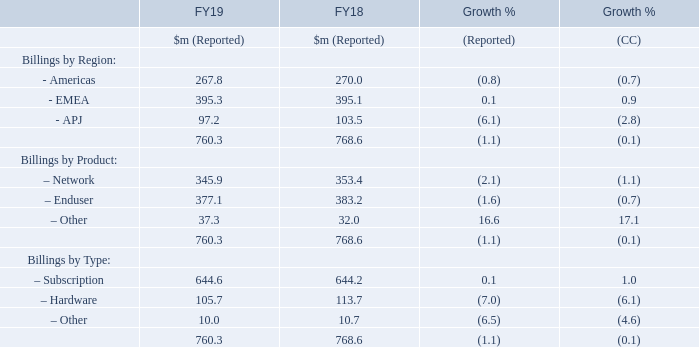Billings
Group reported billings decreased by $8.3 million or 1.1 per cent to $760.3 million in the year-ended 31 March 2019. This represented a 0.1 per cent decrease on a constant currency (“CC”) basis.
Billings by region
Americas Billings attributable to the Americas decreased by $2.2 million to $267.8 million in the period, representing a 0.8 per cent reduction on a reported basis and 0.7 per cent on a constant currency basis; this decrease largely driven by a decline in Enduser products due to the stronger performance in the prior-year compare as a consequence of the impact of the WannaCry ransomware outbreak and the launch of Intercept X, the Group’s next-gen endpoint product, partially offset by an improved performance in UTM sales.
EMEA Billings attributable to EMEA increased by $0.2 million to $395.3 million in the period, representing 0.1 per cent growth on a reported basis and 0.9 per cent growth on a constant currency basis. An increase in sales of Server products being partially offset by a reduction in endpoint and email products.
APJ Billings attributable to APJ decreased by $6.3 million to $97.2 million in the period, representing 6.1 per cent on a reported basis and 2.8 per cent on a constant currency basis. As in the Americas, growth was negatively impacted by the stronger performance in the prior-year compare compounded by a legacy Network product transition in the first-half of the year partially offset by an improvement in sales of Server products.
What was the amount of Group reported billings in 2019? $760.3 million. What was the percentage change in Group reported billings in 2019 from 2018? 1.1 per cent. How is the analysis of Billings broken down in the table? Billings by region, billings by product, billings by type. In which year was the amount of Billings larger? 768.6>760.3
Answer: fy18. What was the change in Other in 2019 from 2018 under Billings by Product?
Answer scale should be: million. 37.3-32.0
Answer: 5.3. What was the average amount of Billings in 2018 and 2019?
Answer scale should be: million. (760.3+768.6)/2
Answer: 764.45. 